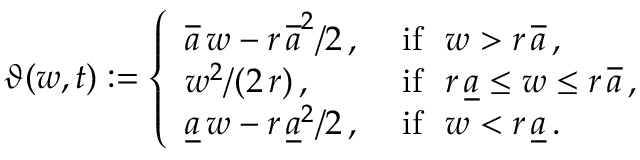<formula> <loc_0><loc_0><loc_500><loc_500>\vartheta ( w , t ) \colon = \left \{ \begin{array} { l l } { \overline { a } \, w - r \, \overline { a } ^ { 2 } / 2 \, , } & { i f \ \ w > r \, \overline { a } \, , } \\ { w ^ { 2 } / ( 2 \, r ) \, , } & { i f \ \ r \, \underline { a } \leq w \leq r \, \overline { a } \, , } \\ { \underline { a } \, w - r \, \underline { a } ^ { 2 } / 2 \, , } & { i f \ \ w < r \, \underline { a } \, . } \end{array}</formula> 